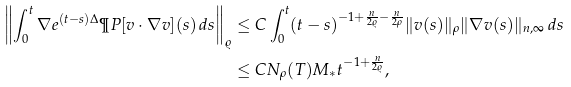Convert formula to latex. <formula><loc_0><loc_0><loc_500><loc_500>\left \| \int _ { 0 } ^ { t } \nabla e ^ { ( t - s ) \Delta } \P P [ v \cdot \nabla v ] ( s ) \, d s \right \| _ { \varrho } & \leq C \int _ { 0 } ^ { t } ( t - s ) ^ { - 1 + \frac { n } { 2 \varrho } - \frac { n } { 2 \rho } } \| v ( s ) \| _ { \rho } \| \nabla v ( s ) \| _ { n , \infty } \, d s \\ & \leq C N _ { \rho } ( T ) M _ { * } t ^ { - 1 + \frac { n } { 2 \varrho } } ,</formula> 